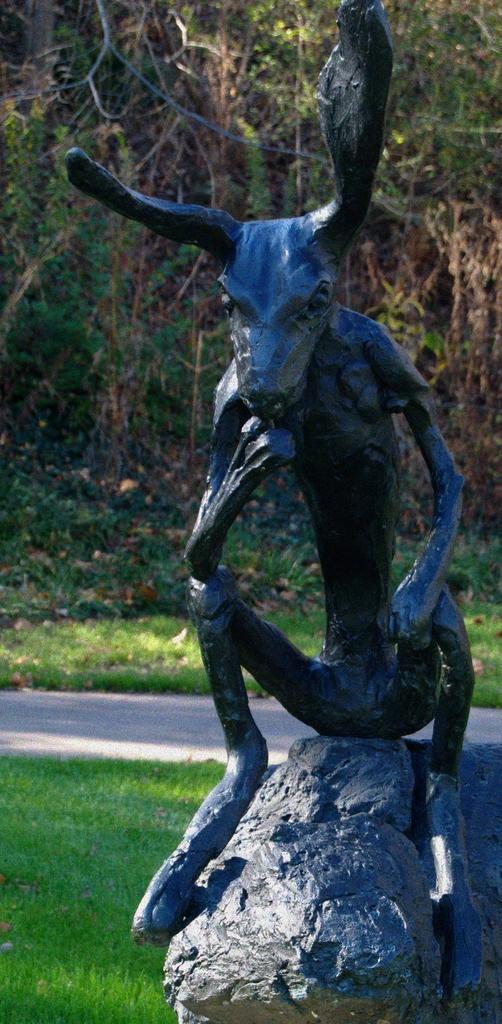How would you summarize this image in a sentence or two? In this image we can see a statue placed on a stone. In the background we can see group of trees. 